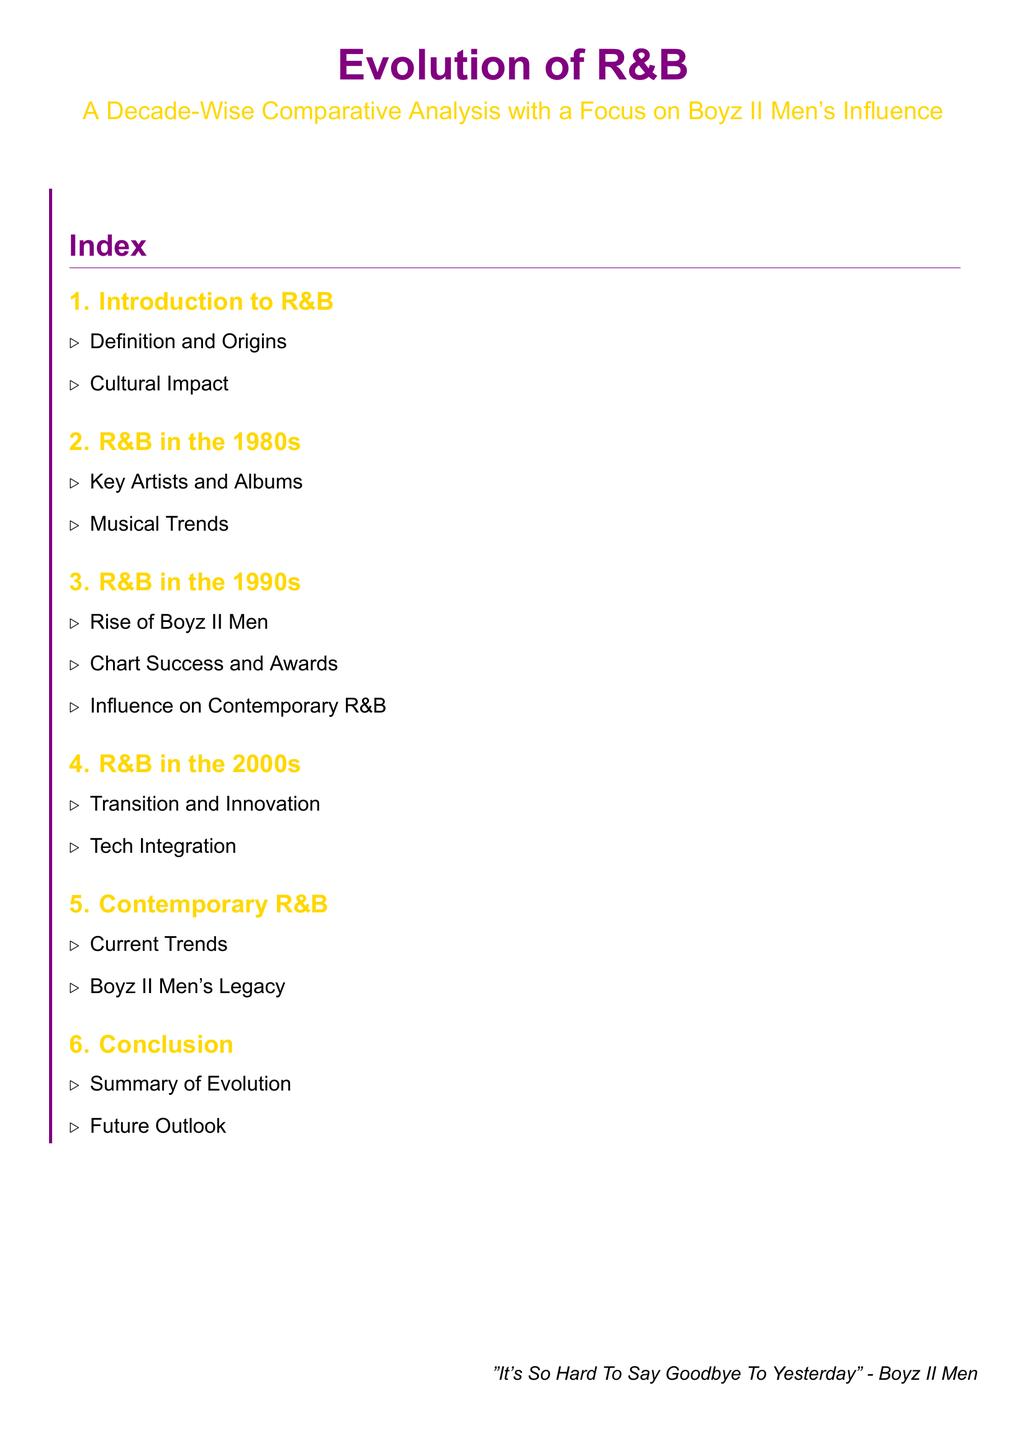What is the focus of the analysis? The focus of the analysis is indicated in the title of the document, emphasizing Boyz II Men's influence in R&B.
Answer: Boyz II Men's influence What decade is highlighted for Boyz II Men's rise? The decade mentioned specifically for Boyz II Men's rise is the 1990s.
Answer: 1990s What type of analysis is the document providing? The document is providing a comparative analysis, as indicated in the title.
Answer: Comparative analysis What musical trends are explored in the 1980s section? The specific trends of the 1980s are not listed in the document, but it indicates that key artists and albums are included.
Answer: Key artists and albums In which section do we find information about Boyz II Men's legacy? Information about Boyz II Men's legacy is found in the Contemporary R&B section.
Answer: Contemporary R&B What is the title of the document? The title gives the focus and context for the content of the document.
Answer: Evolution of R&B What is the purpose of the conclusion section? The conclusion section summarizes the evolution of R&B and outlines future outlooks, as noted in the index.
Answer: Summary of Evolution How many subsections are included in the 1990s? The 1990s section contains three subsections, highlighting various aspects of that decade.
Answer: Three 